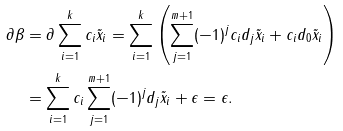<formula> <loc_0><loc_0><loc_500><loc_500>\partial \beta & = \partial \sum _ { i = 1 } ^ { k } c _ { i } \tilde { x } _ { i } = \sum _ { i = 1 } ^ { k } \left ( \sum _ { j = 1 } ^ { m + 1 } ( - 1 ) ^ { j } c _ { i } d _ { j } \tilde { x } _ { i } + c _ { i } d _ { 0 } \tilde { x } _ { i } \right ) \\ & = \sum _ { i = 1 } ^ { k } c _ { i } \sum _ { j = 1 } ^ { m + 1 } ( - 1 ) ^ { j } d _ { j } \tilde { x } _ { i } + \epsilon = \epsilon .</formula> 